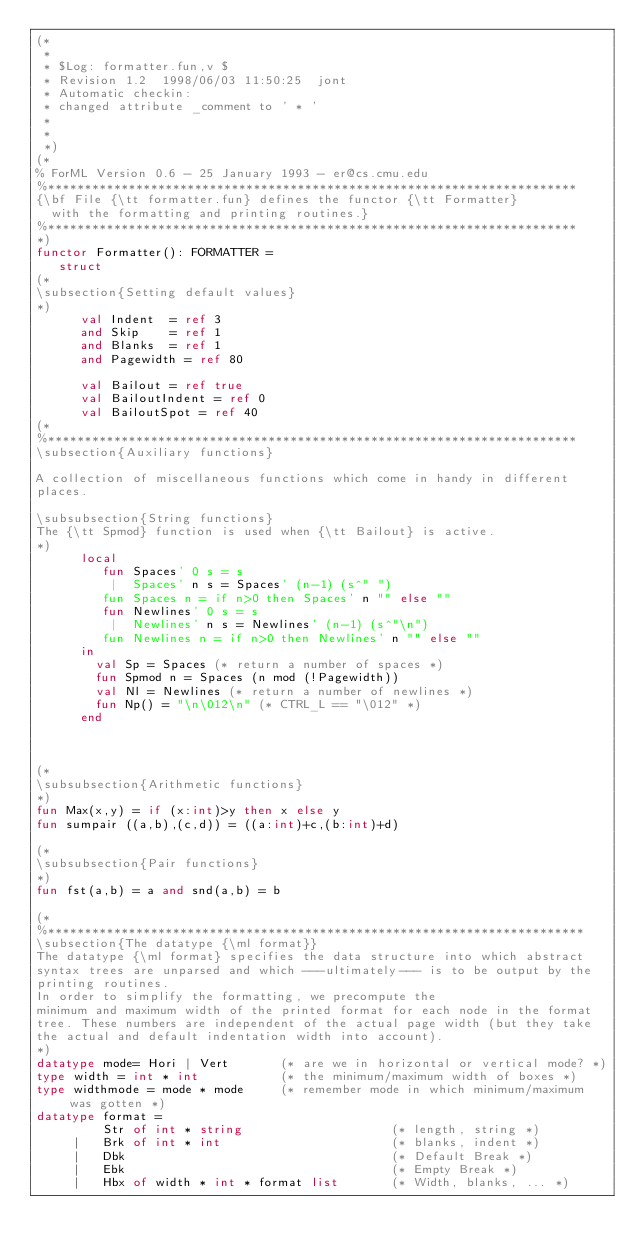Convert code to text. <code><loc_0><loc_0><loc_500><loc_500><_SML_>(*
 *
 * $Log: formatter.fun,v $
 * Revision 1.2  1998/06/03 11:50:25  jont
 * Automatic checkin:
 * changed attribute _comment to ' * '
 *
 *
 *)
(*
% ForML Version 0.6 - 25 January 1993 - er@cs.cmu.edu
%************************************************************************
{\bf File {\tt formatter.fun} defines the functor {\tt Formatter}
  with the formatting and printing routines.}
%************************************************************************
*)
functor Formatter(): FORMATTER =
   struct
(*
\subsection{Setting default values}
*)
      val Indent  = ref 3
      and Skip    = ref 1
      and Blanks  = ref 1
      and Pagewidth = ref 80

      val Bailout = ref true
      val BailoutIndent = ref 0
      val BailoutSpot = ref 40
(*
%************************************************************************
\subsection{Auxiliary functions} 

A collection of miscellaneous functions which come in handy in different
places.

\subsubsection{String functions}
The {\tt Spmod} function is used when {\tt Bailout} is active.
*)
      local
         fun Spaces' 0 s = s
          |  Spaces' n s = Spaces' (n-1) (s^" ")
         fun Spaces n = if n>0 then Spaces' n "" else ""
         fun Newlines' 0 s = s
          |  Newlines' n s = Newlines' (n-1) (s^"\n")
         fun Newlines n = if n>0 then Newlines' n "" else ""
      in
        val Sp = Spaces (* return a number of spaces *)
        fun Spmod n = Spaces (n mod (!Pagewidth))
        val Nl = Newlines (* return a number of newlines *)
        fun Np() = "\n\012\n" (* CTRL_L == "\012" *)
      end 



(*
\subsubsection{Arithmetic functions}
*)
fun Max(x,y) = if (x:int)>y then x else y
fun sumpair ((a,b),(c,d)) = ((a:int)+c,(b:int)+d)

(*
\subsubsection{Pair functions}
*)
fun fst(a,b) = a and snd(a,b) = b

(*
%*************************************************************************
\subsection{The datatype {\ml format}}
The datatype {\ml format} specifies the data structure into which abstract
syntax trees are unparsed and which ---ultimately--- is to be output by the
printing routines.
In order to simplify the formatting, we precompute the
minimum and maximum width of the printed format for each node in the format
tree. These numbers are independent of the actual page width (but they take
the actual and default indentation width into account).
*)
datatype mode= Hori | Vert       (* are we in horizontal or vertical mode? *)
type width = int * int           (* the minimum/maximum width of boxes *)
type widthmode = mode * mode     (* remember mode in which minimum/maximum was gotten *)
datatype format =
         Str of int * string                    (* length, string *)
     |   Brk of int * int                       (* blanks, indent *)
     |   Dbk                                    (* Default Break *)
     |   Ebk                                    (* Empty Break *)
     |   Hbx of width * int * format list       (* Width, blanks, ... *)</code> 